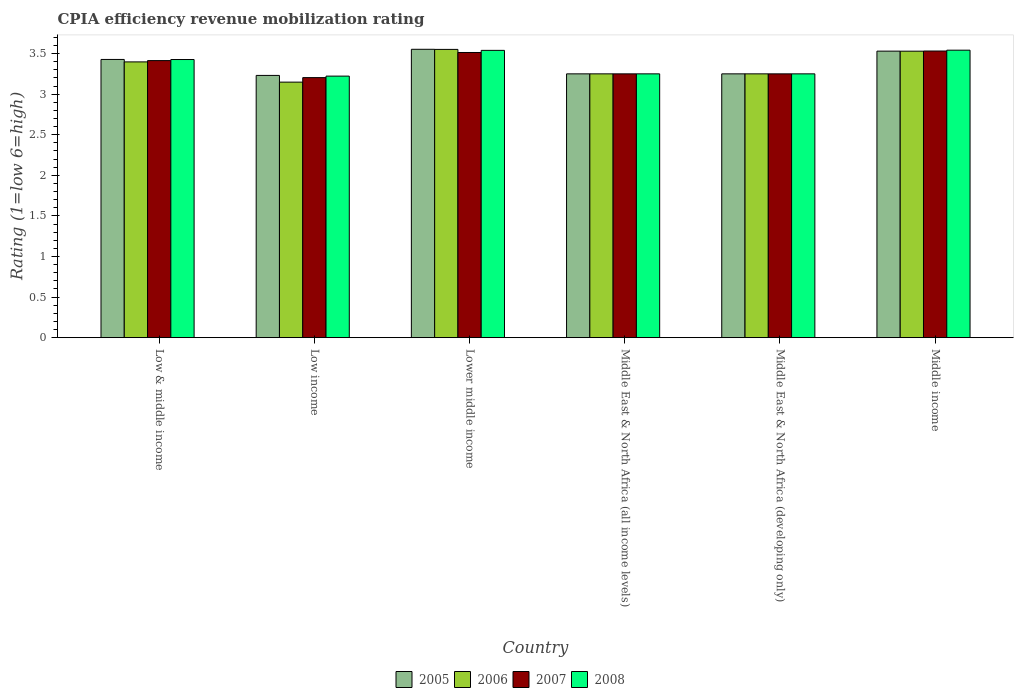How many different coloured bars are there?
Give a very brief answer. 4. How many groups of bars are there?
Provide a short and direct response. 6. Are the number of bars per tick equal to the number of legend labels?
Your answer should be compact. Yes. What is the label of the 1st group of bars from the left?
Offer a terse response. Low & middle income. In how many cases, is the number of bars for a given country not equal to the number of legend labels?
Make the answer very short. 0. What is the CPIA rating in 2005 in Middle income?
Make the answer very short. 3.53. Across all countries, what is the maximum CPIA rating in 2005?
Keep it short and to the point. 3.55. Across all countries, what is the minimum CPIA rating in 2008?
Your answer should be compact. 3.22. In which country was the CPIA rating in 2005 maximum?
Provide a succinct answer. Lower middle income. What is the total CPIA rating in 2008 in the graph?
Your response must be concise. 20.23. What is the difference between the CPIA rating in 2005 in Lower middle income and that in Middle income?
Offer a terse response. 0.02. What is the difference between the CPIA rating in 2005 in Middle East & North Africa (all income levels) and the CPIA rating in 2007 in Middle income?
Keep it short and to the point. -0.28. What is the average CPIA rating in 2007 per country?
Provide a succinct answer. 3.36. In how many countries, is the CPIA rating in 2008 greater than 2?
Provide a short and direct response. 6. What is the ratio of the CPIA rating in 2007 in Low & middle income to that in Lower middle income?
Your response must be concise. 0.97. Is the CPIA rating in 2005 in Middle East & North Africa (all income levels) less than that in Middle East & North Africa (developing only)?
Keep it short and to the point. No. Is the difference between the CPIA rating in 2008 in Low income and Lower middle income greater than the difference between the CPIA rating in 2007 in Low income and Lower middle income?
Ensure brevity in your answer.  No. What is the difference between the highest and the second highest CPIA rating in 2005?
Offer a very short reply. 0.1. What is the difference between the highest and the lowest CPIA rating in 2007?
Provide a short and direct response. 0.33. In how many countries, is the CPIA rating in 2007 greater than the average CPIA rating in 2007 taken over all countries?
Keep it short and to the point. 3. Is the sum of the CPIA rating in 2006 in Low income and Middle income greater than the maximum CPIA rating in 2007 across all countries?
Offer a terse response. Yes. Is it the case that in every country, the sum of the CPIA rating in 2008 and CPIA rating in 2006 is greater than the sum of CPIA rating in 2005 and CPIA rating in 2007?
Ensure brevity in your answer.  No. What does the 4th bar from the right in Middle income represents?
Offer a terse response. 2005. How many bars are there?
Give a very brief answer. 24. Are all the bars in the graph horizontal?
Offer a terse response. No. What is the difference between two consecutive major ticks on the Y-axis?
Offer a very short reply. 0.5. Are the values on the major ticks of Y-axis written in scientific E-notation?
Your answer should be very brief. No. Does the graph contain any zero values?
Give a very brief answer. No. Where does the legend appear in the graph?
Your response must be concise. Bottom center. How many legend labels are there?
Offer a very short reply. 4. How are the legend labels stacked?
Offer a very short reply. Horizontal. What is the title of the graph?
Your response must be concise. CPIA efficiency revenue mobilization rating. What is the label or title of the Y-axis?
Your answer should be compact. Rating (1=low 6=high). What is the Rating (1=low 6=high) of 2005 in Low & middle income?
Your response must be concise. 3.43. What is the Rating (1=low 6=high) in 2006 in Low & middle income?
Your answer should be compact. 3.4. What is the Rating (1=low 6=high) in 2007 in Low & middle income?
Provide a succinct answer. 3.41. What is the Rating (1=low 6=high) of 2008 in Low & middle income?
Your answer should be compact. 3.43. What is the Rating (1=low 6=high) in 2005 in Low income?
Give a very brief answer. 3.23. What is the Rating (1=low 6=high) of 2006 in Low income?
Your answer should be very brief. 3.15. What is the Rating (1=low 6=high) in 2007 in Low income?
Provide a succinct answer. 3.2. What is the Rating (1=low 6=high) of 2008 in Low income?
Offer a very short reply. 3.22. What is the Rating (1=low 6=high) in 2005 in Lower middle income?
Your answer should be compact. 3.55. What is the Rating (1=low 6=high) of 2006 in Lower middle income?
Your answer should be very brief. 3.55. What is the Rating (1=low 6=high) of 2007 in Lower middle income?
Your answer should be very brief. 3.51. What is the Rating (1=low 6=high) of 2008 in Lower middle income?
Offer a very short reply. 3.54. What is the Rating (1=low 6=high) in 2006 in Middle East & North Africa (all income levels)?
Offer a terse response. 3.25. What is the Rating (1=low 6=high) of 2007 in Middle East & North Africa (all income levels)?
Your answer should be very brief. 3.25. What is the Rating (1=low 6=high) in 2005 in Middle East & North Africa (developing only)?
Ensure brevity in your answer.  3.25. What is the Rating (1=low 6=high) in 2006 in Middle East & North Africa (developing only)?
Your answer should be compact. 3.25. What is the Rating (1=low 6=high) of 2007 in Middle East & North Africa (developing only)?
Offer a terse response. 3.25. What is the Rating (1=low 6=high) of 2005 in Middle income?
Give a very brief answer. 3.53. What is the Rating (1=low 6=high) of 2006 in Middle income?
Provide a short and direct response. 3.53. What is the Rating (1=low 6=high) in 2007 in Middle income?
Your answer should be very brief. 3.53. What is the Rating (1=low 6=high) in 2008 in Middle income?
Your answer should be compact. 3.54. Across all countries, what is the maximum Rating (1=low 6=high) in 2005?
Ensure brevity in your answer.  3.55. Across all countries, what is the maximum Rating (1=low 6=high) of 2006?
Ensure brevity in your answer.  3.55. Across all countries, what is the maximum Rating (1=low 6=high) in 2007?
Provide a short and direct response. 3.53. Across all countries, what is the maximum Rating (1=low 6=high) of 2008?
Make the answer very short. 3.54. Across all countries, what is the minimum Rating (1=low 6=high) of 2005?
Provide a short and direct response. 3.23. Across all countries, what is the minimum Rating (1=low 6=high) in 2006?
Ensure brevity in your answer.  3.15. Across all countries, what is the minimum Rating (1=low 6=high) in 2007?
Ensure brevity in your answer.  3.2. Across all countries, what is the minimum Rating (1=low 6=high) in 2008?
Offer a terse response. 3.22. What is the total Rating (1=low 6=high) of 2005 in the graph?
Provide a succinct answer. 20.24. What is the total Rating (1=low 6=high) of 2006 in the graph?
Your answer should be compact. 20.13. What is the total Rating (1=low 6=high) in 2007 in the graph?
Provide a succinct answer. 20.16. What is the total Rating (1=low 6=high) in 2008 in the graph?
Offer a terse response. 20.23. What is the difference between the Rating (1=low 6=high) of 2005 in Low & middle income and that in Low income?
Your answer should be compact. 0.2. What is the difference between the Rating (1=low 6=high) of 2006 in Low & middle income and that in Low income?
Ensure brevity in your answer.  0.25. What is the difference between the Rating (1=low 6=high) of 2007 in Low & middle income and that in Low income?
Keep it short and to the point. 0.21. What is the difference between the Rating (1=low 6=high) in 2008 in Low & middle income and that in Low income?
Your answer should be compact. 0.2. What is the difference between the Rating (1=low 6=high) of 2005 in Low & middle income and that in Lower middle income?
Your answer should be very brief. -0.12. What is the difference between the Rating (1=low 6=high) in 2006 in Low & middle income and that in Lower middle income?
Your response must be concise. -0.15. What is the difference between the Rating (1=low 6=high) of 2007 in Low & middle income and that in Lower middle income?
Make the answer very short. -0.1. What is the difference between the Rating (1=low 6=high) in 2008 in Low & middle income and that in Lower middle income?
Offer a terse response. -0.11. What is the difference between the Rating (1=low 6=high) in 2005 in Low & middle income and that in Middle East & North Africa (all income levels)?
Your response must be concise. 0.18. What is the difference between the Rating (1=low 6=high) in 2006 in Low & middle income and that in Middle East & North Africa (all income levels)?
Offer a terse response. 0.15. What is the difference between the Rating (1=low 6=high) of 2007 in Low & middle income and that in Middle East & North Africa (all income levels)?
Your answer should be very brief. 0.16. What is the difference between the Rating (1=low 6=high) in 2008 in Low & middle income and that in Middle East & North Africa (all income levels)?
Your response must be concise. 0.18. What is the difference between the Rating (1=low 6=high) of 2005 in Low & middle income and that in Middle East & North Africa (developing only)?
Offer a very short reply. 0.18. What is the difference between the Rating (1=low 6=high) of 2006 in Low & middle income and that in Middle East & North Africa (developing only)?
Your response must be concise. 0.15. What is the difference between the Rating (1=low 6=high) in 2007 in Low & middle income and that in Middle East & North Africa (developing only)?
Ensure brevity in your answer.  0.16. What is the difference between the Rating (1=low 6=high) of 2008 in Low & middle income and that in Middle East & North Africa (developing only)?
Your response must be concise. 0.18. What is the difference between the Rating (1=low 6=high) of 2005 in Low & middle income and that in Middle income?
Offer a terse response. -0.1. What is the difference between the Rating (1=low 6=high) of 2006 in Low & middle income and that in Middle income?
Make the answer very short. -0.13. What is the difference between the Rating (1=low 6=high) of 2007 in Low & middle income and that in Middle income?
Your answer should be very brief. -0.12. What is the difference between the Rating (1=low 6=high) in 2008 in Low & middle income and that in Middle income?
Keep it short and to the point. -0.12. What is the difference between the Rating (1=low 6=high) in 2005 in Low income and that in Lower middle income?
Your answer should be very brief. -0.32. What is the difference between the Rating (1=low 6=high) in 2006 in Low income and that in Lower middle income?
Make the answer very short. -0.4. What is the difference between the Rating (1=low 6=high) of 2007 in Low income and that in Lower middle income?
Your answer should be very brief. -0.31. What is the difference between the Rating (1=low 6=high) in 2008 in Low income and that in Lower middle income?
Your answer should be compact. -0.32. What is the difference between the Rating (1=low 6=high) of 2005 in Low income and that in Middle East & North Africa (all income levels)?
Offer a terse response. -0.02. What is the difference between the Rating (1=low 6=high) in 2006 in Low income and that in Middle East & North Africa (all income levels)?
Your answer should be compact. -0.1. What is the difference between the Rating (1=low 6=high) of 2007 in Low income and that in Middle East & North Africa (all income levels)?
Keep it short and to the point. -0.05. What is the difference between the Rating (1=low 6=high) in 2008 in Low income and that in Middle East & North Africa (all income levels)?
Offer a very short reply. -0.03. What is the difference between the Rating (1=low 6=high) in 2005 in Low income and that in Middle East & North Africa (developing only)?
Offer a terse response. -0.02. What is the difference between the Rating (1=low 6=high) in 2006 in Low income and that in Middle East & North Africa (developing only)?
Offer a very short reply. -0.1. What is the difference between the Rating (1=low 6=high) of 2007 in Low income and that in Middle East & North Africa (developing only)?
Offer a terse response. -0.05. What is the difference between the Rating (1=low 6=high) in 2008 in Low income and that in Middle East & North Africa (developing only)?
Offer a terse response. -0.03. What is the difference between the Rating (1=low 6=high) of 2005 in Low income and that in Middle income?
Your response must be concise. -0.3. What is the difference between the Rating (1=low 6=high) of 2006 in Low income and that in Middle income?
Your answer should be compact. -0.38. What is the difference between the Rating (1=low 6=high) in 2007 in Low income and that in Middle income?
Your response must be concise. -0.33. What is the difference between the Rating (1=low 6=high) in 2008 in Low income and that in Middle income?
Offer a very short reply. -0.32. What is the difference between the Rating (1=low 6=high) in 2005 in Lower middle income and that in Middle East & North Africa (all income levels)?
Give a very brief answer. 0.3. What is the difference between the Rating (1=low 6=high) in 2006 in Lower middle income and that in Middle East & North Africa (all income levels)?
Offer a terse response. 0.3. What is the difference between the Rating (1=low 6=high) in 2007 in Lower middle income and that in Middle East & North Africa (all income levels)?
Offer a very short reply. 0.26. What is the difference between the Rating (1=low 6=high) of 2008 in Lower middle income and that in Middle East & North Africa (all income levels)?
Keep it short and to the point. 0.29. What is the difference between the Rating (1=low 6=high) in 2005 in Lower middle income and that in Middle East & North Africa (developing only)?
Your response must be concise. 0.3. What is the difference between the Rating (1=low 6=high) of 2006 in Lower middle income and that in Middle East & North Africa (developing only)?
Your answer should be very brief. 0.3. What is the difference between the Rating (1=low 6=high) of 2007 in Lower middle income and that in Middle East & North Africa (developing only)?
Your answer should be very brief. 0.26. What is the difference between the Rating (1=low 6=high) in 2008 in Lower middle income and that in Middle East & North Africa (developing only)?
Offer a very short reply. 0.29. What is the difference between the Rating (1=low 6=high) in 2005 in Lower middle income and that in Middle income?
Provide a succinct answer. 0.02. What is the difference between the Rating (1=low 6=high) of 2006 in Lower middle income and that in Middle income?
Provide a succinct answer. 0.02. What is the difference between the Rating (1=low 6=high) of 2007 in Lower middle income and that in Middle income?
Keep it short and to the point. -0.02. What is the difference between the Rating (1=low 6=high) of 2008 in Lower middle income and that in Middle income?
Provide a short and direct response. -0. What is the difference between the Rating (1=low 6=high) in 2006 in Middle East & North Africa (all income levels) and that in Middle East & North Africa (developing only)?
Keep it short and to the point. 0. What is the difference between the Rating (1=low 6=high) of 2008 in Middle East & North Africa (all income levels) and that in Middle East & North Africa (developing only)?
Offer a very short reply. 0. What is the difference between the Rating (1=low 6=high) of 2005 in Middle East & North Africa (all income levels) and that in Middle income?
Your answer should be very brief. -0.28. What is the difference between the Rating (1=low 6=high) in 2006 in Middle East & North Africa (all income levels) and that in Middle income?
Your answer should be very brief. -0.28. What is the difference between the Rating (1=low 6=high) of 2007 in Middle East & North Africa (all income levels) and that in Middle income?
Ensure brevity in your answer.  -0.28. What is the difference between the Rating (1=low 6=high) of 2008 in Middle East & North Africa (all income levels) and that in Middle income?
Offer a very short reply. -0.29. What is the difference between the Rating (1=low 6=high) of 2005 in Middle East & North Africa (developing only) and that in Middle income?
Provide a short and direct response. -0.28. What is the difference between the Rating (1=low 6=high) of 2006 in Middle East & North Africa (developing only) and that in Middle income?
Keep it short and to the point. -0.28. What is the difference between the Rating (1=low 6=high) of 2007 in Middle East & North Africa (developing only) and that in Middle income?
Make the answer very short. -0.28. What is the difference between the Rating (1=low 6=high) of 2008 in Middle East & North Africa (developing only) and that in Middle income?
Your answer should be very brief. -0.29. What is the difference between the Rating (1=low 6=high) of 2005 in Low & middle income and the Rating (1=low 6=high) of 2006 in Low income?
Your answer should be compact. 0.28. What is the difference between the Rating (1=low 6=high) in 2005 in Low & middle income and the Rating (1=low 6=high) in 2007 in Low income?
Provide a short and direct response. 0.22. What is the difference between the Rating (1=low 6=high) of 2005 in Low & middle income and the Rating (1=low 6=high) of 2008 in Low income?
Keep it short and to the point. 0.21. What is the difference between the Rating (1=low 6=high) of 2006 in Low & middle income and the Rating (1=low 6=high) of 2007 in Low income?
Ensure brevity in your answer.  0.19. What is the difference between the Rating (1=low 6=high) in 2006 in Low & middle income and the Rating (1=low 6=high) in 2008 in Low income?
Your response must be concise. 0.18. What is the difference between the Rating (1=low 6=high) of 2007 in Low & middle income and the Rating (1=low 6=high) of 2008 in Low income?
Provide a short and direct response. 0.19. What is the difference between the Rating (1=low 6=high) in 2005 in Low & middle income and the Rating (1=low 6=high) in 2006 in Lower middle income?
Keep it short and to the point. -0.12. What is the difference between the Rating (1=low 6=high) of 2005 in Low & middle income and the Rating (1=low 6=high) of 2007 in Lower middle income?
Provide a short and direct response. -0.09. What is the difference between the Rating (1=low 6=high) of 2005 in Low & middle income and the Rating (1=low 6=high) of 2008 in Lower middle income?
Provide a succinct answer. -0.11. What is the difference between the Rating (1=low 6=high) of 2006 in Low & middle income and the Rating (1=low 6=high) of 2007 in Lower middle income?
Provide a succinct answer. -0.12. What is the difference between the Rating (1=low 6=high) in 2006 in Low & middle income and the Rating (1=low 6=high) in 2008 in Lower middle income?
Your response must be concise. -0.14. What is the difference between the Rating (1=low 6=high) of 2007 in Low & middle income and the Rating (1=low 6=high) of 2008 in Lower middle income?
Make the answer very short. -0.13. What is the difference between the Rating (1=low 6=high) of 2005 in Low & middle income and the Rating (1=low 6=high) of 2006 in Middle East & North Africa (all income levels)?
Keep it short and to the point. 0.18. What is the difference between the Rating (1=low 6=high) of 2005 in Low & middle income and the Rating (1=low 6=high) of 2007 in Middle East & North Africa (all income levels)?
Your response must be concise. 0.18. What is the difference between the Rating (1=low 6=high) in 2005 in Low & middle income and the Rating (1=low 6=high) in 2008 in Middle East & North Africa (all income levels)?
Offer a terse response. 0.18. What is the difference between the Rating (1=low 6=high) in 2006 in Low & middle income and the Rating (1=low 6=high) in 2007 in Middle East & North Africa (all income levels)?
Offer a very short reply. 0.15. What is the difference between the Rating (1=low 6=high) in 2006 in Low & middle income and the Rating (1=low 6=high) in 2008 in Middle East & North Africa (all income levels)?
Ensure brevity in your answer.  0.15. What is the difference between the Rating (1=low 6=high) of 2007 in Low & middle income and the Rating (1=low 6=high) of 2008 in Middle East & North Africa (all income levels)?
Ensure brevity in your answer.  0.16. What is the difference between the Rating (1=low 6=high) in 2005 in Low & middle income and the Rating (1=low 6=high) in 2006 in Middle East & North Africa (developing only)?
Keep it short and to the point. 0.18. What is the difference between the Rating (1=low 6=high) of 2005 in Low & middle income and the Rating (1=low 6=high) of 2007 in Middle East & North Africa (developing only)?
Provide a succinct answer. 0.18. What is the difference between the Rating (1=low 6=high) in 2005 in Low & middle income and the Rating (1=low 6=high) in 2008 in Middle East & North Africa (developing only)?
Your response must be concise. 0.18. What is the difference between the Rating (1=low 6=high) of 2006 in Low & middle income and the Rating (1=low 6=high) of 2007 in Middle East & North Africa (developing only)?
Make the answer very short. 0.15. What is the difference between the Rating (1=low 6=high) of 2006 in Low & middle income and the Rating (1=low 6=high) of 2008 in Middle East & North Africa (developing only)?
Offer a very short reply. 0.15. What is the difference between the Rating (1=low 6=high) of 2007 in Low & middle income and the Rating (1=low 6=high) of 2008 in Middle East & North Africa (developing only)?
Make the answer very short. 0.16. What is the difference between the Rating (1=low 6=high) of 2005 in Low & middle income and the Rating (1=low 6=high) of 2006 in Middle income?
Keep it short and to the point. -0.1. What is the difference between the Rating (1=low 6=high) in 2005 in Low & middle income and the Rating (1=low 6=high) in 2007 in Middle income?
Your response must be concise. -0.1. What is the difference between the Rating (1=low 6=high) in 2005 in Low & middle income and the Rating (1=low 6=high) in 2008 in Middle income?
Provide a short and direct response. -0.11. What is the difference between the Rating (1=low 6=high) in 2006 in Low & middle income and the Rating (1=low 6=high) in 2007 in Middle income?
Provide a short and direct response. -0.13. What is the difference between the Rating (1=low 6=high) in 2006 in Low & middle income and the Rating (1=low 6=high) in 2008 in Middle income?
Ensure brevity in your answer.  -0.14. What is the difference between the Rating (1=low 6=high) of 2007 in Low & middle income and the Rating (1=low 6=high) of 2008 in Middle income?
Offer a very short reply. -0.13. What is the difference between the Rating (1=low 6=high) of 2005 in Low income and the Rating (1=low 6=high) of 2006 in Lower middle income?
Provide a short and direct response. -0.32. What is the difference between the Rating (1=low 6=high) of 2005 in Low income and the Rating (1=low 6=high) of 2007 in Lower middle income?
Offer a very short reply. -0.28. What is the difference between the Rating (1=low 6=high) in 2005 in Low income and the Rating (1=low 6=high) in 2008 in Lower middle income?
Offer a very short reply. -0.31. What is the difference between the Rating (1=low 6=high) in 2006 in Low income and the Rating (1=low 6=high) in 2007 in Lower middle income?
Your answer should be compact. -0.36. What is the difference between the Rating (1=low 6=high) in 2006 in Low income and the Rating (1=low 6=high) in 2008 in Lower middle income?
Offer a terse response. -0.39. What is the difference between the Rating (1=low 6=high) in 2007 in Low income and the Rating (1=low 6=high) in 2008 in Lower middle income?
Your answer should be very brief. -0.34. What is the difference between the Rating (1=low 6=high) of 2005 in Low income and the Rating (1=low 6=high) of 2006 in Middle East & North Africa (all income levels)?
Your answer should be very brief. -0.02. What is the difference between the Rating (1=low 6=high) in 2005 in Low income and the Rating (1=low 6=high) in 2007 in Middle East & North Africa (all income levels)?
Your answer should be very brief. -0.02. What is the difference between the Rating (1=low 6=high) of 2005 in Low income and the Rating (1=low 6=high) of 2008 in Middle East & North Africa (all income levels)?
Your answer should be compact. -0.02. What is the difference between the Rating (1=low 6=high) in 2006 in Low income and the Rating (1=low 6=high) in 2007 in Middle East & North Africa (all income levels)?
Keep it short and to the point. -0.1. What is the difference between the Rating (1=low 6=high) of 2006 in Low income and the Rating (1=low 6=high) of 2008 in Middle East & North Africa (all income levels)?
Your answer should be compact. -0.1. What is the difference between the Rating (1=low 6=high) in 2007 in Low income and the Rating (1=low 6=high) in 2008 in Middle East & North Africa (all income levels)?
Provide a short and direct response. -0.05. What is the difference between the Rating (1=low 6=high) in 2005 in Low income and the Rating (1=low 6=high) in 2006 in Middle East & North Africa (developing only)?
Offer a terse response. -0.02. What is the difference between the Rating (1=low 6=high) of 2005 in Low income and the Rating (1=low 6=high) of 2007 in Middle East & North Africa (developing only)?
Offer a very short reply. -0.02. What is the difference between the Rating (1=low 6=high) in 2005 in Low income and the Rating (1=low 6=high) in 2008 in Middle East & North Africa (developing only)?
Your answer should be compact. -0.02. What is the difference between the Rating (1=low 6=high) of 2006 in Low income and the Rating (1=low 6=high) of 2007 in Middle East & North Africa (developing only)?
Offer a terse response. -0.1. What is the difference between the Rating (1=low 6=high) in 2006 in Low income and the Rating (1=low 6=high) in 2008 in Middle East & North Africa (developing only)?
Ensure brevity in your answer.  -0.1. What is the difference between the Rating (1=low 6=high) of 2007 in Low income and the Rating (1=low 6=high) of 2008 in Middle East & North Africa (developing only)?
Keep it short and to the point. -0.05. What is the difference between the Rating (1=low 6=high) of 2005 in Low income and the Rating (1=low 6=high) of 2006 in Middle income?
Make the answer very short. -0.3. What is the difference between the Rating (1=low 6=high) of 2005 in Low income and the Rating (1=low 6=high) of 2007 in Middle income?
Provide a succinct answer. -0.3. What is the difference between the Rating (1=low 6=high) in 2005 in Low income and the Rating (1=low 6=high) in 2008 in Middle income?
Your answer should be compact. -0.31. What is the difference between the Rating (1=low 6=high) of 2006 in Low income and the Rating (1=low 6=high) of 2007 in Middle income?
Offer a very short reply. -0.38. What is the difference between the Rating (1=low 6=high) of 2006 in Low income and the Rating (1=low 6=high) of 2008 in Middle income?
Make the answer very short. -0.39. What is the difference between the Rating (1=low 6=high) of 2007 in Low income and the Rating (1=low 6=high) of 2008 in Middle income?
Your response must be concise. -0.34. What is the difference between the Rating (1=low 6=high) of 2005 in Lower middle income and the Rating (1=low 6=high) of 2006 in Middle East & North Africa (all income levels)?
Provide a succinct answer. 0.3. What is the difference between the Rating (1=low 6=high) of 2005 in Lower middle income and the Rating (1=low 6=high) of 2007 in Middle East & North Africa (all income levels)?
Keep it short and to the point. 0.3. What is the difference between the Rating (1=low 6=high) of 2005 in Lower middle income and the Rating (1=low 6=high) of 2008 in Middle East & North Africa (all income levels)?
Ensure brevity in your answer.  0.3. What is the difference between the Rating (1=low 6=high) in 2006 in Lower middle income and the Rating (1=low 6=high) in 2007 in Middle East & North Africa (all income levels)?
Your response must be concise. 0.3. What is the difference between the Rating (1=low 6=high) of 2006 in Lower middle income and the Rating (1=low 6=high) of 2008 in Middle East & North Africa (all income levels)?
Keep it short and to the point. 0.3. What is the difference between the Rating (1=low 6=high) of 2007 in Lower middle income and the Rating (1=low 6=high) of 2008 in Middle East & North Africa (all income levels)?
Your answer should be very brief. 0.26. What is the difference between the Rating (1=low 6=high) in 2005 in Lower middle income and the Rating (1=low 6=high) in 2006 in Middle East & North Africa (developing only)?
Your answer should be very brief. 0.3. What is the difference between the Rating (1=low 6=high) of 2005 in Lower middle income and the Rating (1=low 6=high) of 2007 in Middle East & North Africa (developing only)?
Give a very brief answer. 0.3. What is the difference between the Rating (1=low 6=high) in 2005 in Lower middle income and the Rating (1=low 6=high) in 2008 in Middle East & North Africa (developing only)?
Offer a terse response. 0.3. What is the difference between the Rating (1=low 6=high) of 2006 in Lower middle income and the Rating (1=low 6=high) of 2007 in Middle East & North Africa (developing only)?
Provide a short and direct response. 0.3. What is the difference between the Rating (1=low 6=high) of 2006 in Lower middle income and the Rating (1=low 6=high) of 2008 in Middle East & North Africa (developing only)?
Your answer should be compact. 0.3. What is the difference between the Rating (1=low 6=high) in 2007 in Lower middle income and the Rating (1=low 6=high) in 2008 in Middle East & North Africa (developing only)?
Your response must be concise. 0.26. What is the difference between the Rating (1=low 6=high) of 2005 in Lower middle income and the Rating (1=low 6=high) of 2006 in Middle income?
Give a very brief answer. 0.02. What is the difference between the Rating (1=low 6=high) in 2005 in Lower middle income and the Rating (1=low 6=high) in 2007 in Middle income?
Give a very brief answer. 0.02. What is the difference between the Rating (1=low 6=high) of 2005 in Lower middle income and the Rating (1=low 6=high) of 2008 in Middle income?
Keep it short and to the point. 0.01. What is the difference between the Rating (1=low 6=high) of 2006 in Lower middle income and the Rating (1=low 6=high) of 2008 in Middle income?
Offer a terse response. 0.01. What is the difference between the Rating (1=low 6=high) in 2007 in Lower middle income and the Rating (1=low 6=high) in 2008 in Middle income?
Make the answer very short. -0.03. What is the difference between the Rating (1=low 6=high) of 2005 in Middle East & North Africa (all income levels) and the Rating (1=low 6=high) of 2008 in Middle East & North Africa (developing only)?
Your answer should be compact. 0. What is the difference between the Rating (1=low 6=high) in 2006 in Middle East & North Africa (all income levels) and the Rating (1=low 6=high) in 2008 in Middle East & North Africa (developing only)?
Your answer should be compact. 0. What is the difference between the Rating (1=low 6=high) of 2007 in Middle East & North Africa (all income levels) and the Rating (1=low 6=high) of 2008 in Middle East & North Africa (developing only)?
Make the answer very short. 0. What is the difference between the Rating (1=low 6=high) of 2005 in Middle East & North Africa (all income levels) and the Rating (1=low 6=high) of 2006 in Middle income?
Offer a terse response. -0.28. What is the difference between the Rating (1=low 6=high) in 2005 in Middle East & North Africa (all income levels) and the Rating (1=low 6=high) in 2007 in Middle income?
Offer a very short reply. -0.28. What is the difference between the Rating (1=low 6=high) of 2005 in Middle East & North Africa (all income levels) and the Rating (1=low 6=high) of 2008 in Middle income?
Provide a succinct answer. -0.29. What is the difference between the Rating (1=low 6=high) in 2006 in Middle East & North Africa (all income levels) and the Rating (1=low 6=high) in 2007 in Middle income?
Give a very brief answer. -0.28. What is the difference between the Rating (1=low 6=high) of 2006 in Middle East & North Africa (all income levels) and the Rating (1=low 6=high) of 2008 in Middle income?
Offer a very short reply. -0.29. What is the difference between the Rating (1=low 6=high) of 2007 in Middle East & North Africa (all income levels) and the Rating (1=low 6=high) of 2008 in Middle income?
Offer a very short reply. -0.29. What is the difference between the Rating (1=low 6=high) of 2005 in Middle East & North Africa (developing only) and the Rating (1=low 6=high) of 2006 in Middle income?
Your response must be concise. -0.28. What is the difference between the Rating (1=low 6=high) of 2005 in Middle East & North Africa (developing only) and the Rating (1=low 6=high) of 2007 in Middle income?
Provide a succinct answer. -0.28. What is the difference between the Rating (1=low 6=high) of 2005 in Middle East & North Africa (developing only) and the Rating (1=low 6=high) of 2008 in Middle income?
Provide a succinct answer. -0.29. What is the difference between the Rating (1=low 6=high) in 2006 in Middle East & North Africa (developing only) and the Rating (1=low 6=high) in 2007 in Middle income?
Your response must be concise. -0.28. What is the difference between the Rating (1=low 6=high) of 2006 in Middle East & North Africa (developing only) and the Rating (1=low 6=high) of 2008 in Middle income?
Offer a very short reply. -0.29. What is the difference between the Rating (1=low 6=high) in 2007 in Middle East & North Africa (developing only) and the Rating (1=low 6=high) in 2008 in Middle income?
Your response must be concise. -0.29. What is the average Rating (1=low 6=high) in 2005 per country?
Give a very brief answer. 3.37. What is the average Rating (1=low 6=high) of 2006 per country?
Give a very brief answer. 3.35. What is the average Rating (1=low 6=high) of 2007 per country?
Provide a short and direct response. 3.36. What is the average Rating (1=low 6=high) of 2008 per country?
Provide a short and direct response. 3.37. What is the difference between the Rating (1=low 6=high) in 2005 and Rating (1=low 6=high) in 2006 in Low & middle income?
Provide a succinct answer. 0.03. What is the difference between the Rating (1=low 6=high) of 2005 and Rating (1=low 6=high) of 2007 in Low & middle income?
Provide a short and direct response. 0.01. What is the difference between the Rating (1=low 6=high) in 2006 and Rating (1=low 6=high) in 2007 in Low & middle income?
Your answer should be compact. -0.02. What is the difference between the Rating (1=low 6=high) of 2006 and Rating (1=low 6=high) of 2008 in Low & middle income?
Your answer should be very brief. -0.03. What is the difference between the Rating (1=low 6=high) of 2007 and Rating (1=low 6=high) of 2008 in Low & middle income?
Offer a terse response. -0.01. What is the difference between the Rating (1=low 6=high) of 2005 and Rating (1=low 6=high) of 2006 in Low income?
Your answer should be very brief. 0.08. What is the difference between the Rating (1=low 6=high) of 2005 and Rating (1=low 6=high) of 2007 in Low income?
Your response must be concise. 0.03. What is the difference between the Rating (1=low 6=high) of 2005 and Rating (1=low 6=high) of 2008 in Low income?
Give a very brief answer. 0.01. What is the difference between the Rating (1=low 6=high) in 2006 and Rating (1=low 6=high) in 2007 in Low income?
Provide a short and direct response. -0.06. What is the difference between the Rating (1=low 6=high) of 2006 and Rating (1=low 6=high) of 2008 in Low income?
Ensure brevity in your answer.  -0.07. What is the difference between the Rating (1=low 6=high) of 2007 and Rating (1=low 6=high) of 2008 in Low income?
Your answer should be very brief. -0.02. What is the difference between the Rating (1=low 6=high) of 2005 and Rating (1=low 6=high) of 2006 in Lower middle income?
Your answer should be compact. 0. What is the difference between the Rating (1=low 6=high) in 2005 and Rating (1=low 6=high) in 2007 in Lower middle income?
Keep it short and to the point. 0.04. What is the difference between the Rating (1=low 6=high) in 2005 and Rating (1=low 6=high) in 2008 in Lower middle income?
Provide a short and direct response. 0.01. What is the difference between the Rating (1=low 6=high) in 2006 and Rating (1=low 6=high) in 2007 in Lower middle income?
Your answer should be compact. 0.04. What is the difference between the Rating (1=low 6=high) in 2006 and Rating (1=low 6=high) in 2008 in Lower middle income?
Provide a short and direct response. 0.01. What is the difference between the Rating (1=low 6=high) in 2007 and Rating (1=low 6=high) in 2008 in Lower middle income?
Offer a very short reply. -0.03. What is the difference between the Rating (1=low 6=high) of 2005 and Rating (1=low 6=high) of 2006 in Middle East & North Africa (all income levels)?
Give a very brief answer. 0. What is the difference between the Rating (1=low 6=high) in 2006 and Rating (1=low 6=high) in 2007 in Middle East & North Africa (all income levels)?
Provide a short and direct response. 0. What is the difference between the Rating (1=low 6=high) of 2006 and Rating (1=low 6=high) of 2008 in Middle East & North Africa (all income levels)?
Your response must be concise. 0. What is the difference between the Rating (1=low 6=high) in 2005 and Rating (1=low 6=high) in 2007 in Middle East & North Africa (developing only)?
Your answer should be compact. 0. What is the difference between the Rating (1=low 6=high) of 2006 and Rating (1=low 6=high) of 2008 in Middle East & North Africa (developing only)?
Your response must be concise. 0. What is the difference between the Rating (1=low 6=high) of 2007 and Rating (1=low 6=high) of 2008 in Middle East & North Africa (developing only)?
Offer a very short reply. 0. What is the difference between the Rating (1=low 6=high) of 2005 and Rating (1=low 6=high) of 2006 in Middle income?
Provide a short and direct response. 0. What is the difference between the Rating (1=low 6=high) of 2005 and Rating (1=low 6=high) of 2007 in Middle income?
Keep it short and to the point. -0. What is the difference between the Rating (1=low 6=high) of 2005 and Rating (1=low 6=high) of 2008 in Middle income?
Offer a very short reply. -0.01. What is the difference between the Rating (1=low 6=high) in 2006 and Rating (1=low 6=high) in 2007 in Middle income?
Your answer should be compact. -0. What is the difference between the Rating (1=low 6=high) of 2006 and Rating (1=low 6=high) of 2008 in Middle income?
Provide a short and direct response. -0.01. What is the difference between the Rating (1=low 6=high) in 2007 and Rating (1=low 6=high) in 2008 in Middle income?
Your response must be concise. -0.01. What is the ratio of the Rating (1=low 6=high) in 2005 in Low & middle income to that in Low income?
Provide a short and direct response. 1.06. What is the ratio of the Rating (1=low 6=high) in 2006 in Low & middle income to that in Low income?
Ensure brevity in your answer.  1.08. What is the ratio of the Rating (1=low 6=high) in 2007 in Low & middle income to that in Low income?
Keep it short and to the point. 1.07. What is the ratio of the Rating (1=low 6=high) of 2008 in Low & middle income to that in Low income?
Make the answer very short. 1.06. What is the ratio of the Rating (1=low 6=high) of 2005 in Low & middle income to that in Lower middle income?
Your answer should be compact. 0.96. What is the ratio of the Rating (1=low 6=high) of 2006 in Low & middle income to that in Lower middle income?
Your answer should be compact. 0.96. What is the ratio of the Rating (1=low 6=high) in 2007 in Low & middle income to that in Lower middle income?
Your answer should be compact. 0.97. What is the ratio of the Rating (1=low 6=high) of 2008 in Low & middle income to that in Lower middle income?
Your answer should be very brief. 0.97. What is the ratio of the Rating (1=low 6=high) of 2005 in Low & middle income to that in Middle East & North Africa (all income levels)?
Offer a terse response. 1.05. What is the ratio of the Rating (1=low 6=high) in 2006 in Low & middle income to that in Middle East & North Africa (all income levels)?
Offer a very short reply. 1.05. What is the ratio of the Rating (1=low 6=high) in 2007 in Low & middle income to that in Middle East & North Africa (all income levels)?
Your answer should be very brief. 1.05. What is the ratio of the Rating (1=low 6=high) of 2008 in Low & middle income to that in Middle East & North Africa (all income levels)?
Offer a very short reply. 1.05. What is the ratio of the Rating (1=low 6=high) in 2005 in Low & middle income to that in Middle East & North Africa (developing only)?
Keep it short and to the point. 1.05. What is the ratio of the Rating (1=low 6=high) of 2006 in Low & middle income to that in Middle East & North Africa (developing only)?
Provide a short and direct response. 1.05. What is the ratio of the Rating (1=low 6=high) in 2007 in Low & middle income to that in Middle East & North Africa (developing only)?
Your response must be concise. 1.05. What is the ratio of the Rating (1=low 6=high) of 2008 in Low & middle income to that in Middle East & North Africa (developing only)?
Make the answer very short. 1.05. What is the ratio of the Rating (1=low 6=high) of 2006 in Low & middle income to that in Middle income?
Provide a short and direct response. 0.96. What is the ratio of the Rating (1=low 6=high) of 2007 in Low & middle income to that in Middle income?
Provide a short and direct response. 0.97. What is the ratio of the Rating (1=low 6=high) of 2008 in Low & middle income to that in Middle income?
Ensure brevity in your answer.  0.97. What is the ratio of the Rating (1=low 6=high) in 2005 in Low income to that in Lower middle income?
Your answer should be very brief. 0.91. What is the ratio of the Rating (1=low 6=high) of 2006 in Low income to that in Lower middle income?
Provide a short and direct response. 0.89. What is the ratio of the Rating (1=low 6=high) of 2007 in Low income to that in Lower middle income?
Provide a short and direct response. 0.91. What is the ratio of the Rating (1=low 6=high) in 2008 in Low income to that in Lower middle income?
Make the answer very short. 0.91. What is the ratio of the Rating (1=low 6=high) in 2006 in Low income to that in Middle East & North Africa (all income levels)?
Offer a very short reply. 0.97. What is the ratio of the Rating (1=low 6=high) of 2007 in Low income to that in Middle East & North Africa (all income levels)?
Provide a succinct answer. 0.99. What is the ratio of the Rating (1=low 6=high) in 2006 in Low income to that in Middle East & North Africa (developing only)?
Offer a terse response. 0.97. What is the ratio of the Rating (1=low 6=high) of 2007 in Low income to that in Middle East & North Africa (developing only)?
Make the answer very short. 0.99. What is the ratio of the Rating (1=low 6=high) of 2008 in Low income to that in Middle East & North Africa (developing only)?
Your response must be concise. 0.99. What is the ratio of the Rating (1=low 6=high) in 2005 in Low income to that in Middle income?
Provide a succinct answer. 0.92. What is the ratio of the Rating (1=low 6=high) in 2006 in Low income to that in Middle income?
Your answer should be very brief. 0.89. What is the ratio of the Rating (1=low 6=high) of 2007 in Low income to that in Middle income?
Offer a terse response. 0.91. What is the ratio of the Rating (1=low 6=high) in 2008 in Low income to that in Middle income?
Provide a succinct answer. 0.91. What is the ratio of the Rating (1=low 6=high) of 2005 in Lower middle income to that in Middle East & North Africa (all income levels)?
Your answer should be compact. 1.09. What is the ratio of the Rating (1=low 6=high) in 2006 in Lower middle income to that in Middle East & North Africa (all income levels)?
Provide a short and direct response. 1.09. What is the ratio of the Rating (1=low 6=high) in 2007 in Lower middle income to that in Middle East & North Africa (all income levels)?
Your answer should be compact. 1.08. What is the ratio of the Rating (1=low 6=high) in 2008 in Lower middle income to that in Middle East & North Africa (all income levels)?
Give a very brief answer. 1.09. What is the ratio of the Rating (1=low 6=high) in 2005 in Lower middle income to that in Middle East & North Africa (developing only)?
Offer a terse response. 1.09. What is the ratio of the Rating (1=low 6=high) of 2006 in Lower middle income to that in Middle East & North Africa (developing only)?
Give a very brief answer. 1.09. What is the ratio of the Rating (1=low 6=high) in 2007 in Lower middle income to that in Middle East & North Africa (developing only)?
Make the answer very short. 1.08. What is the ratio of the Rating (1=low 6=high) of 2008 in Lower middle income to that in Middle East & North Africa (developing only)?
Your answer should be very brief. 1.09. What is the ratio of the Rating (1=low 6=high) in 2005 in Lower middle income to that in Middle income?
Provide a short and direct response. 1.01. What is the ratio of the Rating (1=low 6=high) of 2008 in Lower middle income to that in Middle income?
Your answer should be very brief. 1. What is the ratio of the Rating (1=low 6=high) of 2005 in Middle East & North Africa (all income levels) to that in Middle East & North Africa (developing only)?
Your answer should be very brief. 1. What is the ratio of the Rating (1=low 6=high) of 2006 in Middle East & North Africa (all income levels) to that in Middle East & North Africa (developing only)?
Ensure brevity in your answer.  1. What is the ratio of the Rating (1=low 6=high) in 2005 in Middle East & North Africa (all income levels) to that in Middle income?
Keep it short and to the point. 0.92. What is the ratio of the Rating (1=low 6=high) of 2006 in Middle East & North Africa (all income levels) to that in Middle income?
Give a very brief answer. 0.92. What is the ratio of the Rating (1=low 6=high) of 2007 in Middle East & North Africa (all income levels) to that in Middle income?
Provide a short and direct response. 0.92. What is the ratio of the Rating (1=low 6=high) in 2008 in Middle East & North Africa (all income levels) to that in Middle income?
Ensure brevity in your answer.  0.92. What is the ratio of the Rating (1=low 6=high) in 2005 in Middle East & North Africa (developing only) to that in Middle income?
Your answer should be very brief. 0.92. What is the ratio of the Rating (1=low 6=high) of 2006 in Middle East & North Africa (developing only) to that in Middle income?
Make the answer very short. 0.92. What is the ratio of the Rating (1=low 6=high) in 2007 in Middle East & North Africa (developing only) to that in Middle income?
Provide a short and direct response. 0.92. What is the ratio of the Rating (1=low 6=high) in 2008 in Middle East & North Africa (developing only) to that in Middle income?
Offer a very short reply. 0.92. What is the difference between the highest and the second highest Rating (1=low 6=high) of 2005?
Keep it short and to the point. 0.02. What is the difference between the highest and the second highest Rating (1=low 6=high) of 2006?
Offer a terse response. 0.02. What is the difference between the highest and the second highest Rating (1=low 6=high) in 2007?
Give a very brief answer. 0.02. What is the difference between the highest and the second highest Rating (1=low 6=high) in 2008?
Ensure brevity in your answer.  0. What is the difference between the highest and the lowest Rating (1=low 6=high) in 2005?
Your response must be concise. 0.32. What is the difference between the highest and the lowest Rating (1=low 6=high) in 2006?
Keep it short and to the point. 0.4. What is the difference between the highest and the lowest Rating (1=low 6=high) of 2007?
Offer a very short reply. 0.33. What is the difference between the highest and the lowest Rating (1=low 6=high) of 2008?
Offer a very short reply. 0.32. 